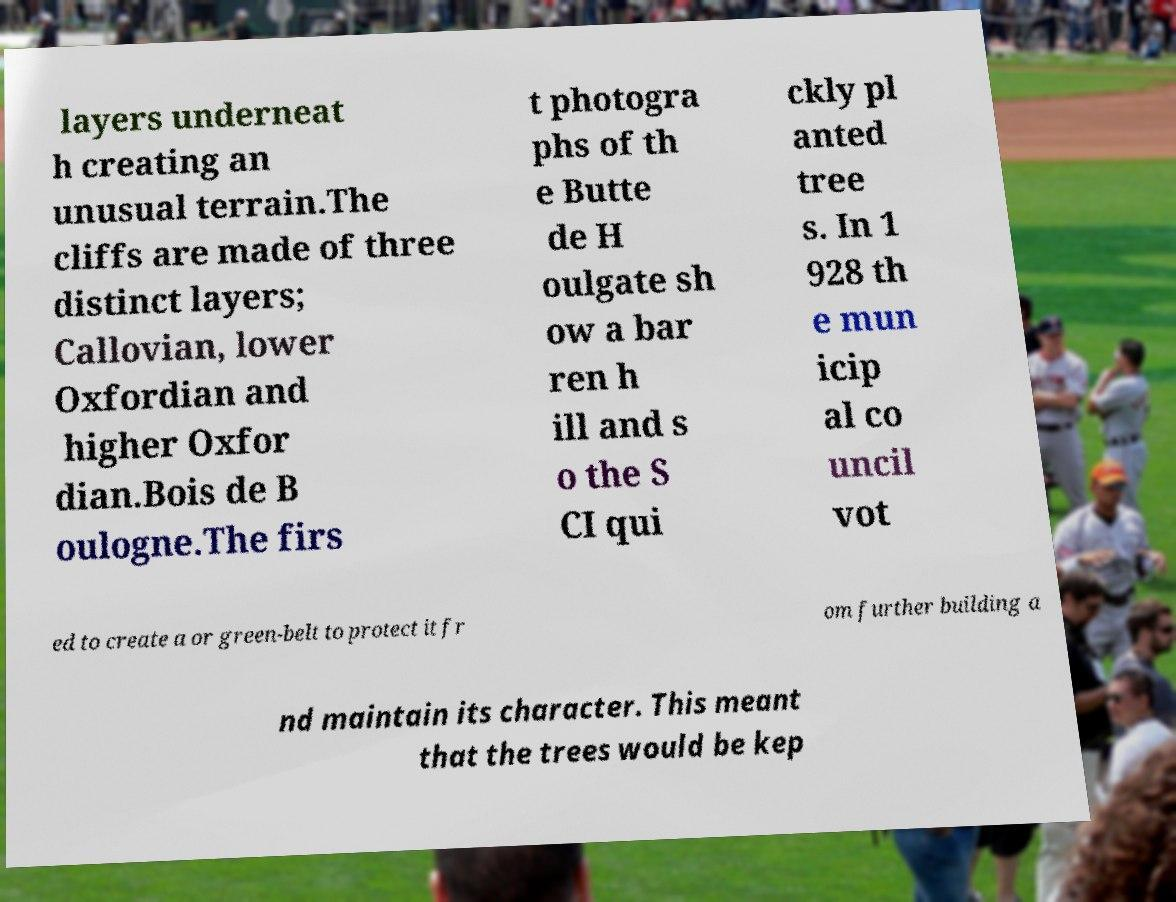What messages or text are displayed in this image? I need them in a readable, typed format. layers underneat h creating an unusual terrain.The cliffs are made of three distinct layers; Callovian, lower Oxfordian and higher Oxfor dian.Bois de B oulogne.The firs t photogra phs of th e Butte de H oulgate sh ow a bar ren h ill and s o the S CI qui ckly pl anted tree s. In 1 928 th e mun icip al co uncil vot ed to create a or green-belt to protect it fr om further building a nd maintain its character. This meant that the trees would be kep 